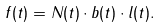Convert formula to latex. <formula><loc_0><loc_0><loc_500><loc_500>f ( t ) = N ( t ) \cdot b ( t ) \cdot l ( t ) .</formula> 